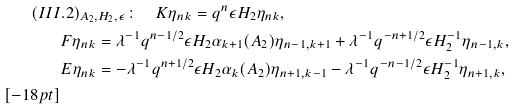<formula> <loc_0><loc_0><loc_500><loc_500>( I I I & . 2 ) _ { A _ { 2 } , H _ { 2 } , \epsilon } \colon \quad K \eta _ { n k } = q ^ { n } \epsilon H _ { 2 } \eta _ { n k } , \\ & F \eta _ { n k } = \lambda ^ { - 1 } q ^ { n - 1 / 2 } \epsilon H _ { 2 } \alpha _ { k + 1 } ( A _ { 2 } ) \eta _ { n - 1 , k + 1 } + \lambda ^ { - 1 } q ^ { - n + 1 / 2 } \epsilon H _ { 2 } ^ { - 1 } \eta _ { n - 1 , k } , \\ & E \eta _ { n k } = - \lambda ^ { - 1 } q ^ { n + 1 / 2 } \epsilon H _ { 2 } \alpha _ { k } ( A _ { 2 } ) \eta _ { n + 1 , k - 1 } - \lambda ^ { - 1 } q ^ { - n - 1 / 2 } \epsilon H _ { 2 } ^ { - 1 } \eta _ { n + 1 , k } , \\ [ - 1 8 p t ]</formula> 